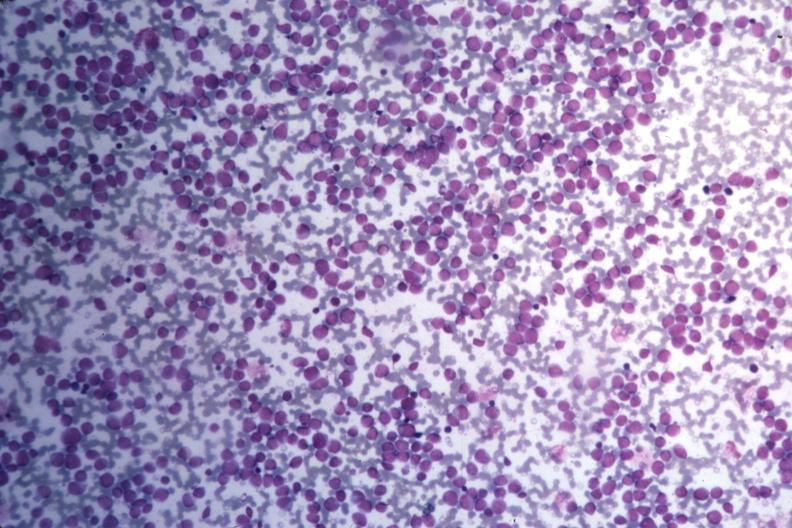s angiogram present?
Answer the question using a single word or phrase. No 